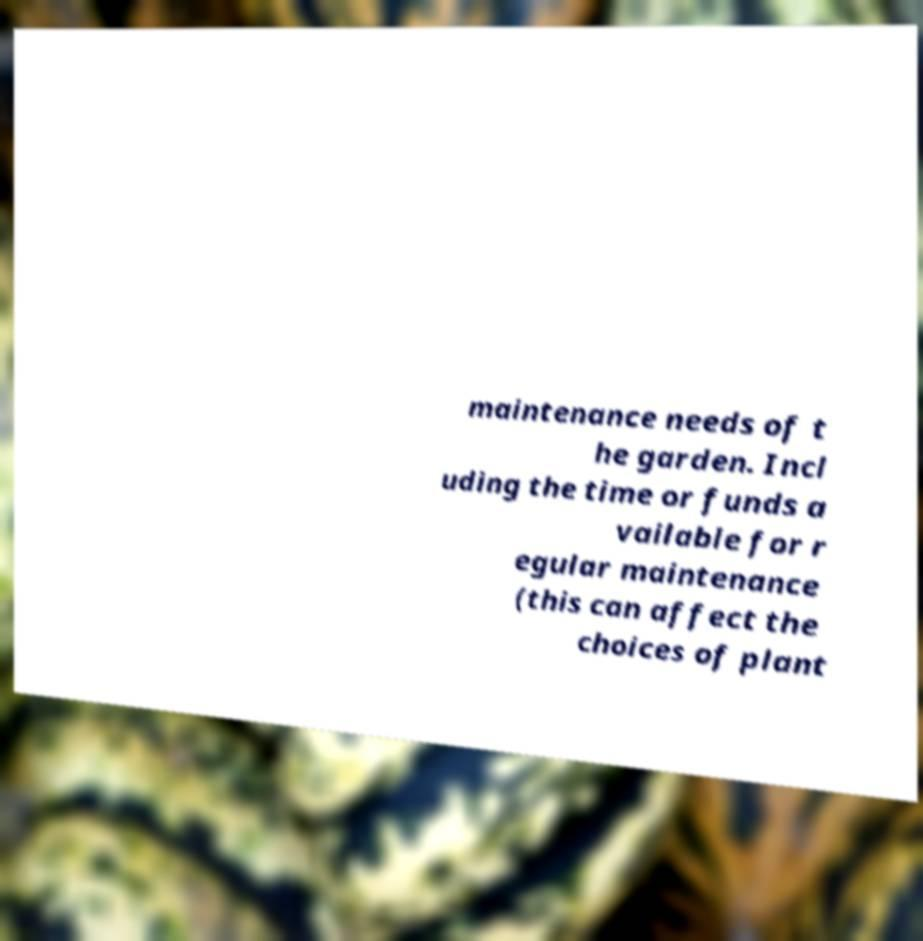What messages or text are displayed in this image? I need them in a readable, typed format. maintenance needs of t he garden. Incl uding the time or funds a vailable for r egular maintenance (this can affect the choices of plant 